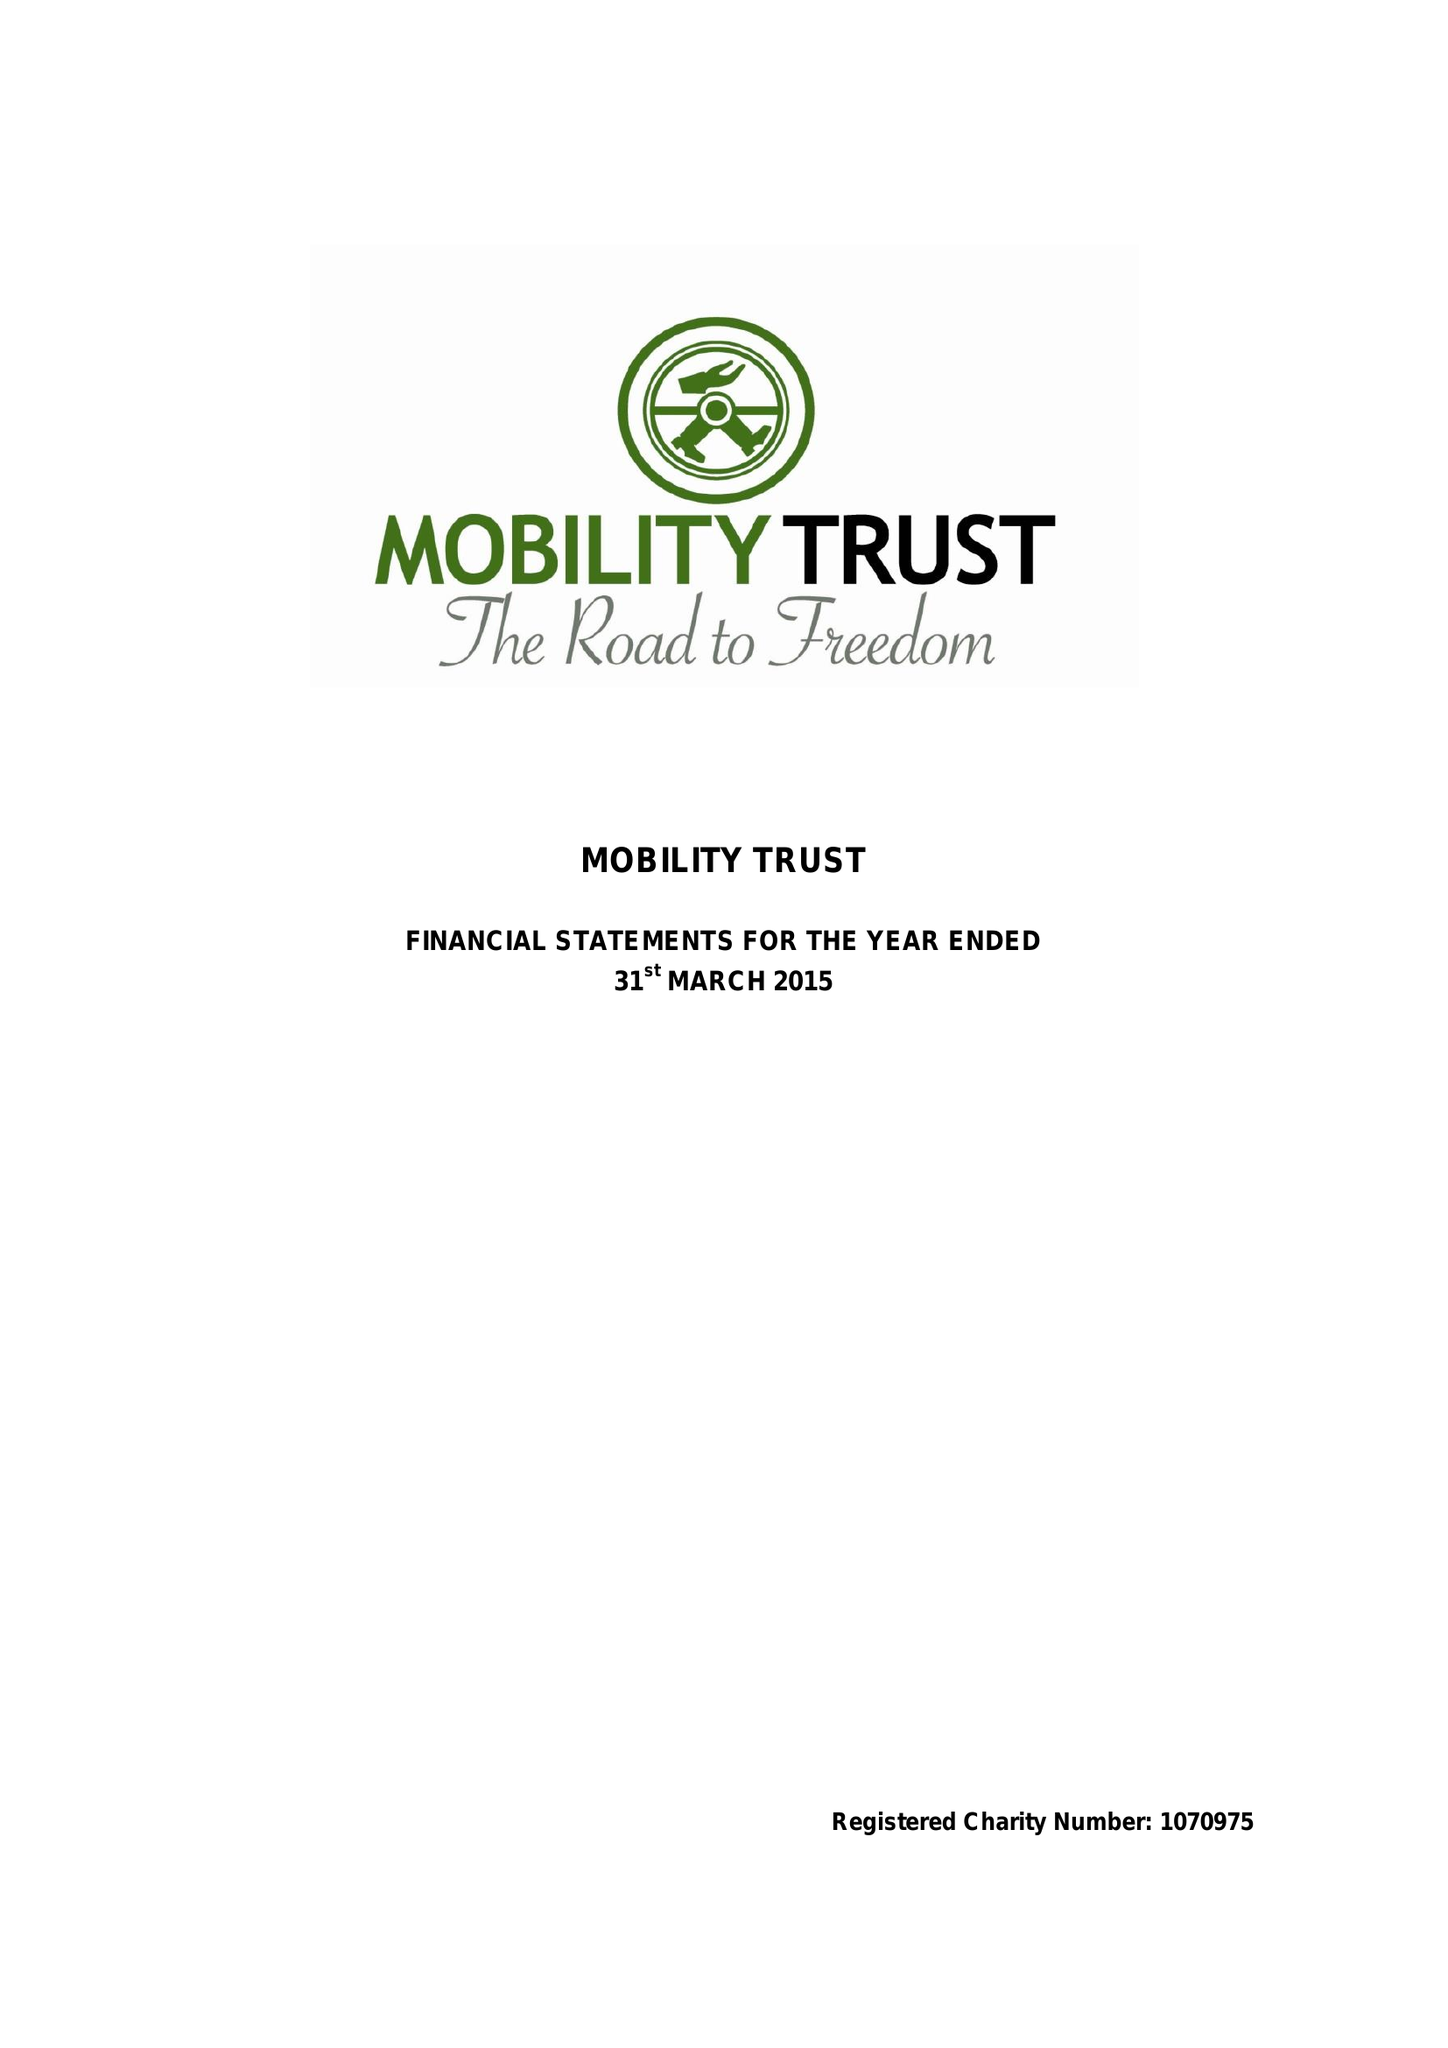What is the value for the spending_annually_in_british_pounds?
Answer the question using a single word or phrase. 333355.00 